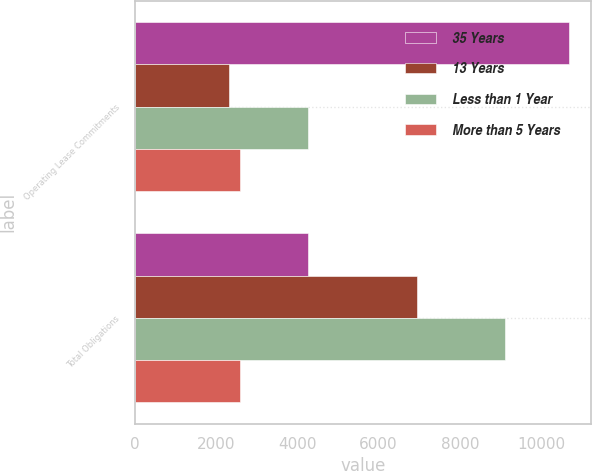<chart> <loc_0><loc_0><loc_500><loc_500><stacked_bar_chart><ecel><fcel>Operating Lease Commitments<fcel>Total Obligations<nl><fcel>35 Years<fcel>10690<fcel>4267<nl><fcel>13 Years<fcel>2313<fcel>6932<nl><fcel>Less than 1 Year<fcel>4267<fcel>9105<nl><fcel>More than 5 Years<fcel>2592<fcel>2592<nl></chart> 